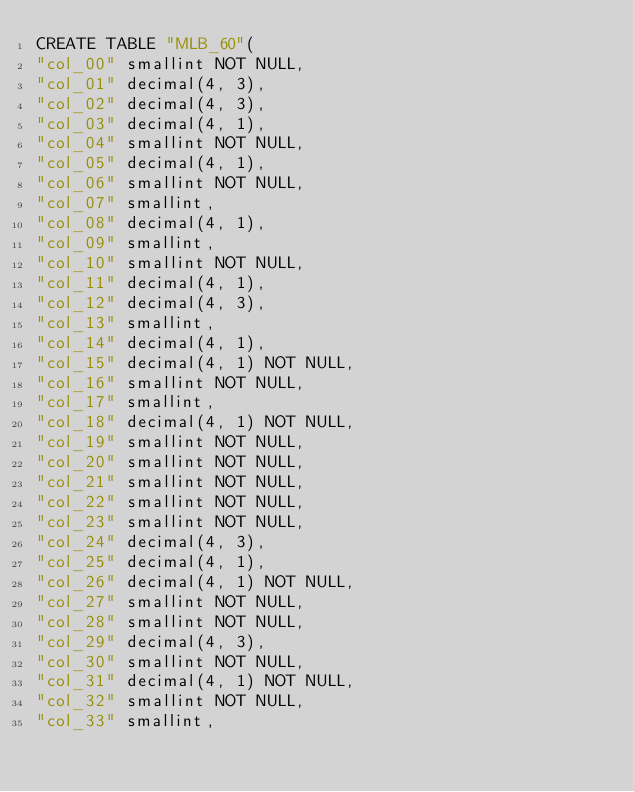Convert code to text. <code><loc_0><loc_0><loc_500><loc_500><_SQL_>CREATE TABLE "MLB_60"(
"col_00" smallint NOT NULL,
"col_01" decimal(4, 3),
"col_02" decimal(4, 3),
"col_03" decimal(4, 1),
"col_04" smallint NOT NULL,
"col_05" decimal(4, 1),
"col_06" smallint NOT NULL,
"col_07" smallint,
"col_08" decimal(4, 1),
"col_09" smallint,
"col_10" smallint NOT NULL,
"col_11" decimal(4, 1),
"col_12" decimal(4, 3),
"col_13" smallint,
"col_14" decimal(4, 1),
"col_15" decimal(4, 1) NOT NULL,
"col_16" smallint NOT NULL,
"col_17" smallint,
"col_18" decimal(4, 1) NOT NULL,
"col_19" smallint NOT NULL,
"col_20" smallint NOT NULL,
"col_21" smallint NOT NULL,
"col_22" smallint NOT NULL,
"col_23" smallint NOT NULL,
"col_24" decimal(4, 3),
"col_25" decimal(4, 1),
"col_26" decimal(4, 1) NOT NULL,
"col_27" smallint NOT NULL,
"col_28" smallint NOT NULL,
"col_29" decimal(4, 3),
"col_30" smallint NOT NULL,
"col_31" decimal(4, 1) NOT NULL,
"col_32" smallint NOT NULL,
"col_33" smallint,</code> 